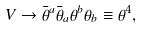<formula> <loc_0><loc_0><loc_500><loc_500>V \to \bar { \theta } ^ { a } \bar { \theta } _ { a } \theta ^ { b } \theta _ { b } \equiv \theta ^ { 4 } ,</formula> 